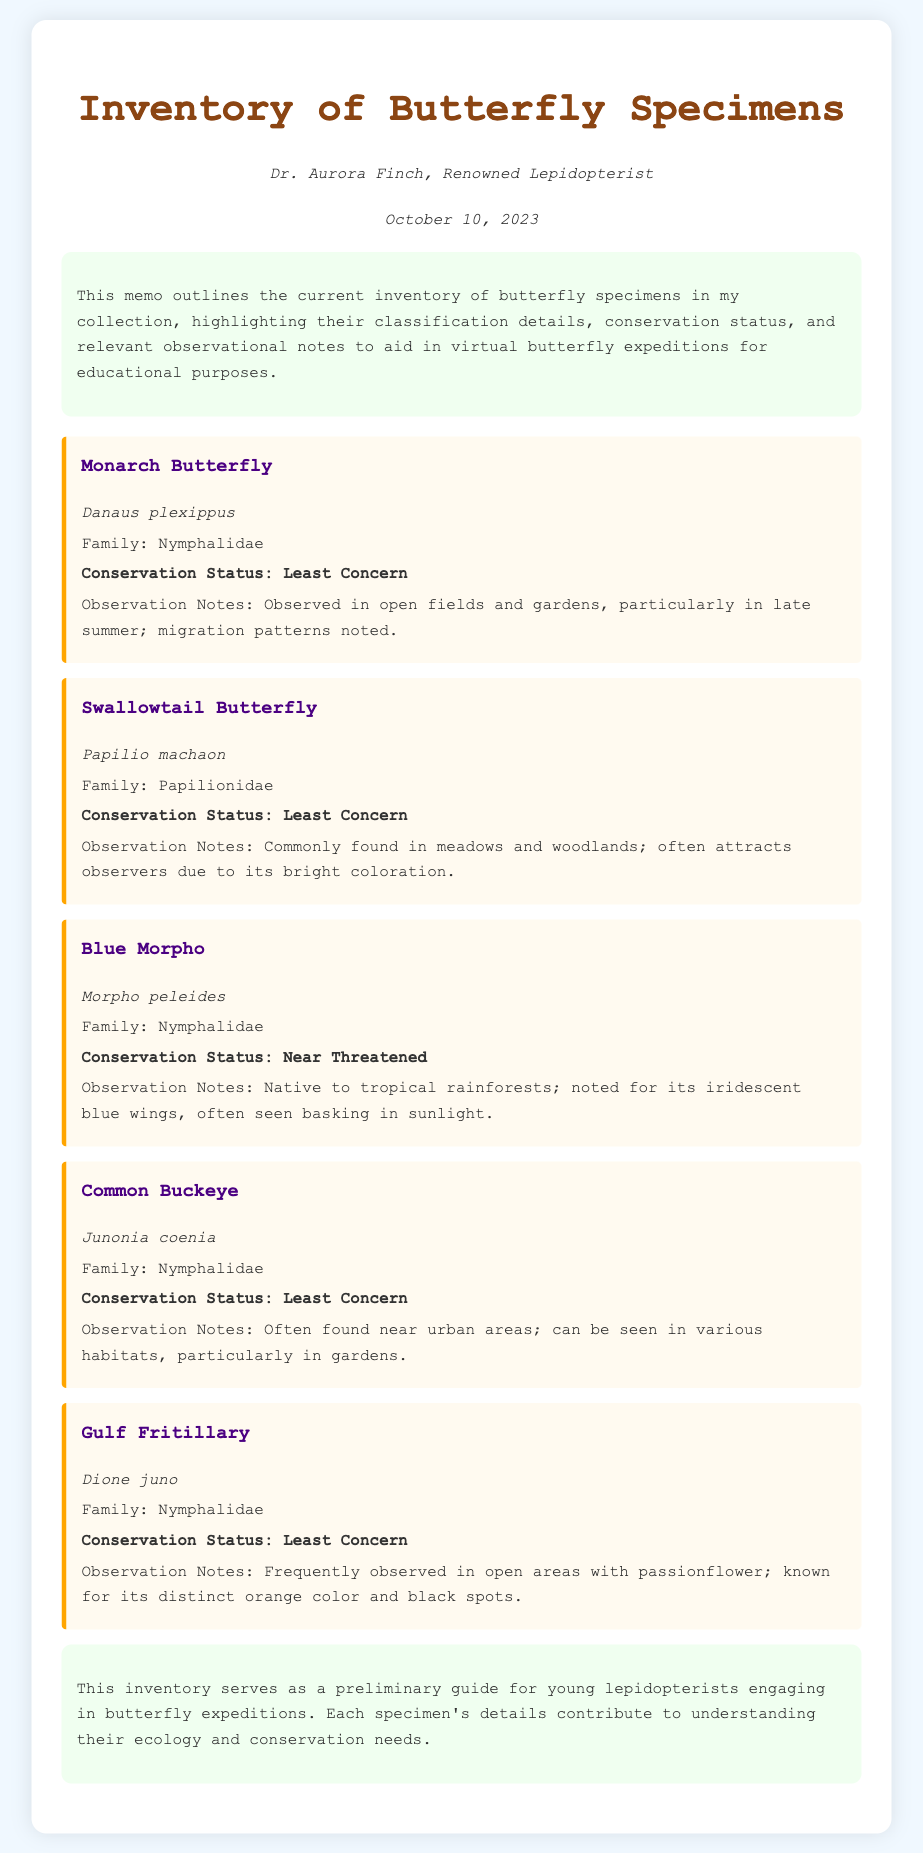What is the title of the memo? The title of the memo is found at the top of the document.
Answer: Inventory of Butterfly Specimens Who is the author of the memo? The author's name is mentioned below the title in the document.
Answer: Dr. Aurora Finch When was the memo published? The publication date is indicated in the date section of the document.
Answer: October 10, 2023 What is the conservation status of the Blue Morpho? The conservation status for each butterfly is specified in the respective sections.
Answer: Near Threatened Which butterfly has the scientific name Danaus plexippus? The scientific names are listed under each butterfly’s common name.
Answer: Monarch Butterfly How many butterfly specimens are listed in the inventory? Counting the separate specimen entries provides the total.
Answer: Five What family does the Swallowtail Butterfly belong to? Each specimen details include their family classification.
Answer: Papilionidae Which butterfly is noted for its migration patterns? The observation notes include details about behaviors and characteristics of each butterfly.
Answer: Monarch Butterfly Where is the Gulf Fritillary commonly observed? Observation notes describe typical habitats for each butterfly.
Answer: Open areas with passionflower 